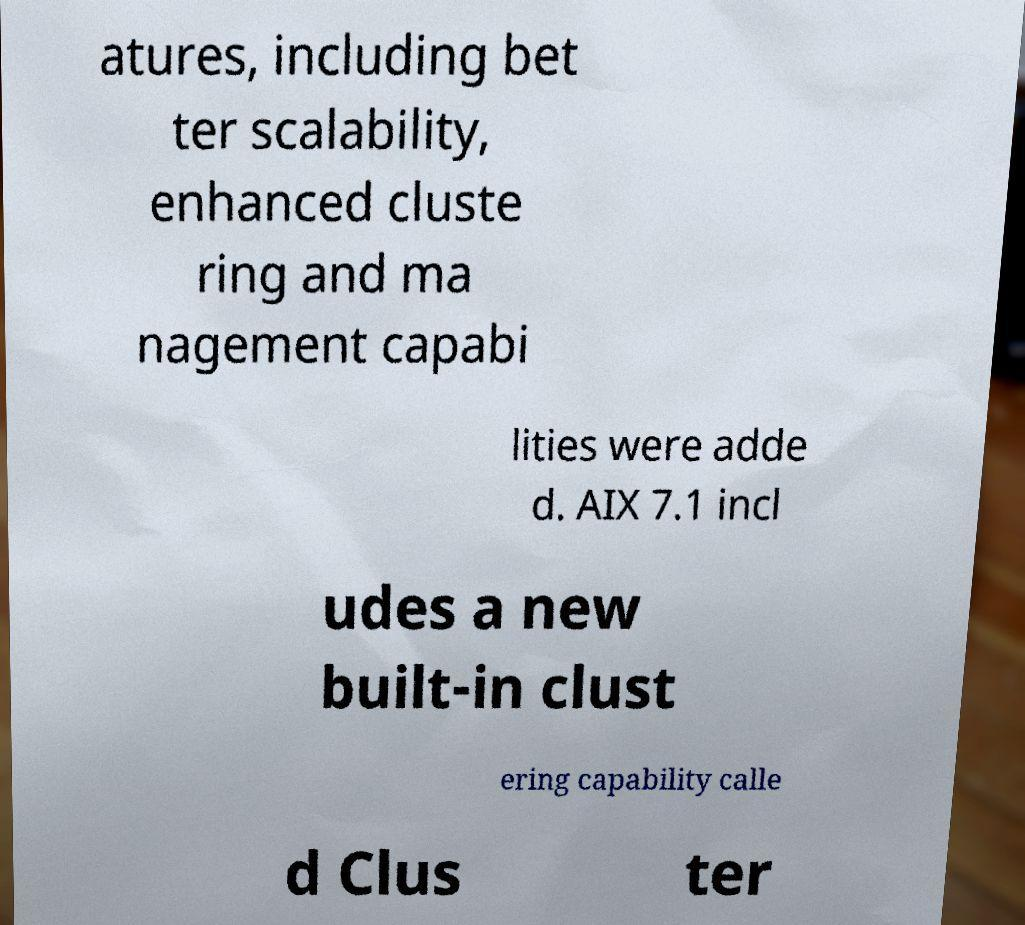For documentation purposes, I need the text within this image transcribed. Could you provide that? atures, including bet ter scalability, enhanced cluste ring and ma nagement capabi lities were adde d. AIX 7.1 incl udes a new built-in clust ering capability calle d Clus ter 